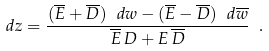<formula> <loc_0><loc_0><loc_500><loc_500>d z = \frac { ( \overline { E } + \overline { D } ) \ d w - ( \overline { E } - \overline { D } ) \ d \overline { w } } { \overline { E } \, D + E \, \overline { D } } \ .</formula> 